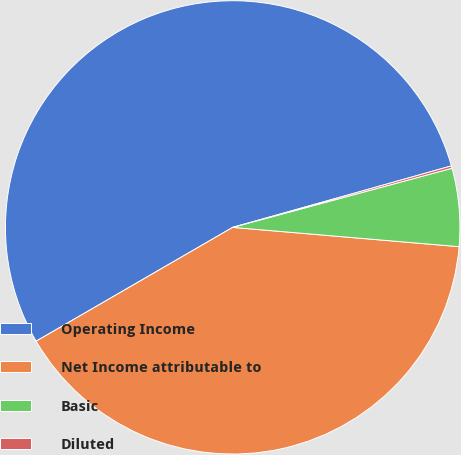Convert chart to OTSL. <chart><loc_0><loc_0><loc_500><loc_500><pie_chart><fcel>Operating Income<fcel>Net Income attributable to<fcel>Basic<fcel>Diluted<nl><fcel>54.0%<fcel>40.27%<fcel>5.56%<fcel>0.17%<nl></chart> 